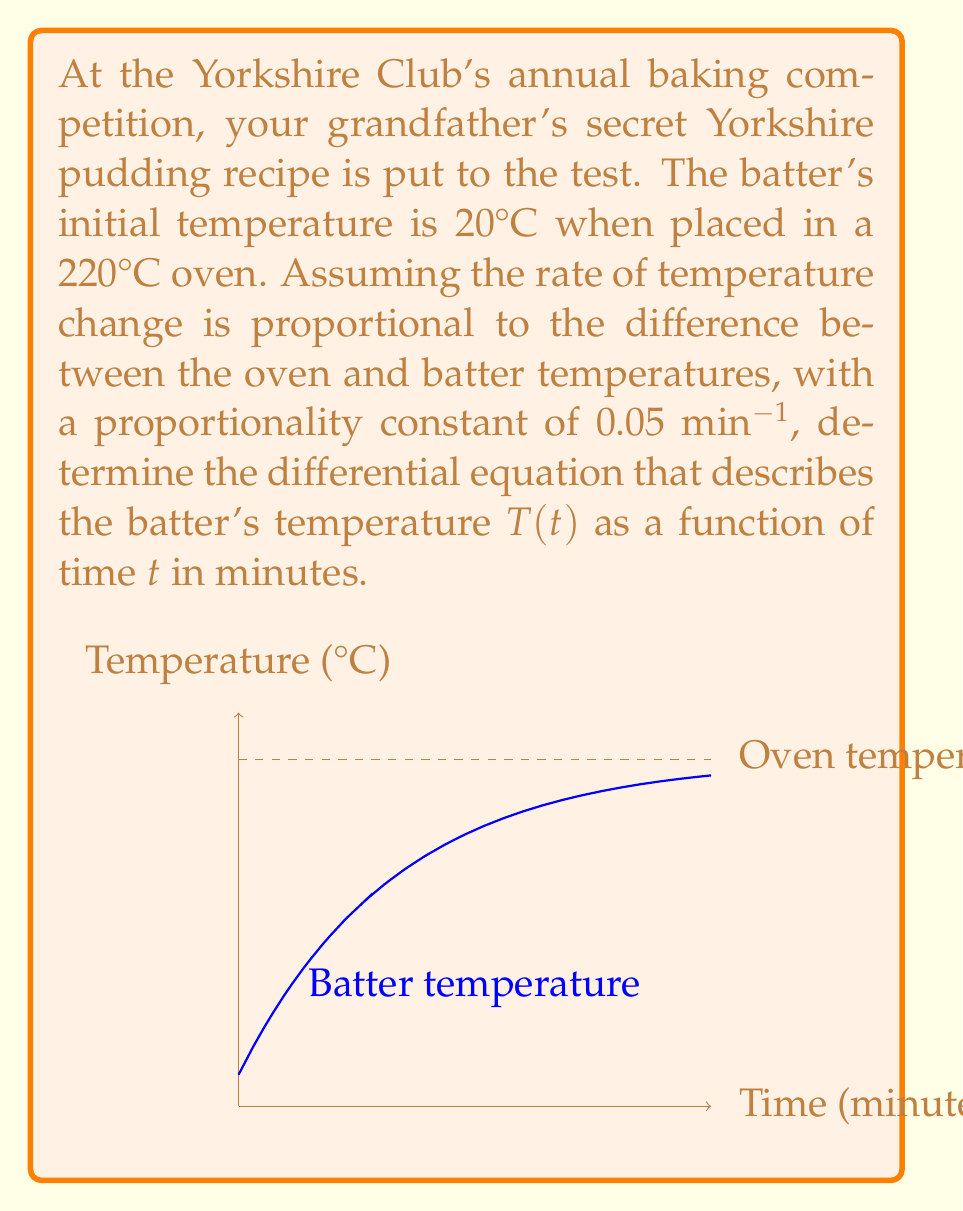Give your solution to this math problem. Let's approach this step-by-step:

1) We're dealing with Newton's Law of Cooling/Heating, which states that the rate of change of temperature is proportional to the difference between the object's temperature and the ambient temperature.

2) Let T(t) be the batter's temperature at time t, and T_o be the oven temperature.

3) The rate of change of temperature with respect to time is represented by dT/dt.

4) The difference between the oven and batter temperatures is (T_o - T).

5) The proportionality constant is given as 0.05 min^(-1).

6) Putting this together, we get the differential equation:

   $$\frac{dT}{dt} = k(T_o - T)$$

   where k is the proportionality constant.

7) Substituting the given values:
   T_o = 220°C
   k = 0.05 min^(-1)

8) The final differential equation is:

   $$\frac{dT}{dt} = 0.05(220 - T)$$

This equation describes how the batter's temperature changes over time in the oven.
Answer: $$\frac{dT}{dt} = 0.05(220 - T)$$ 